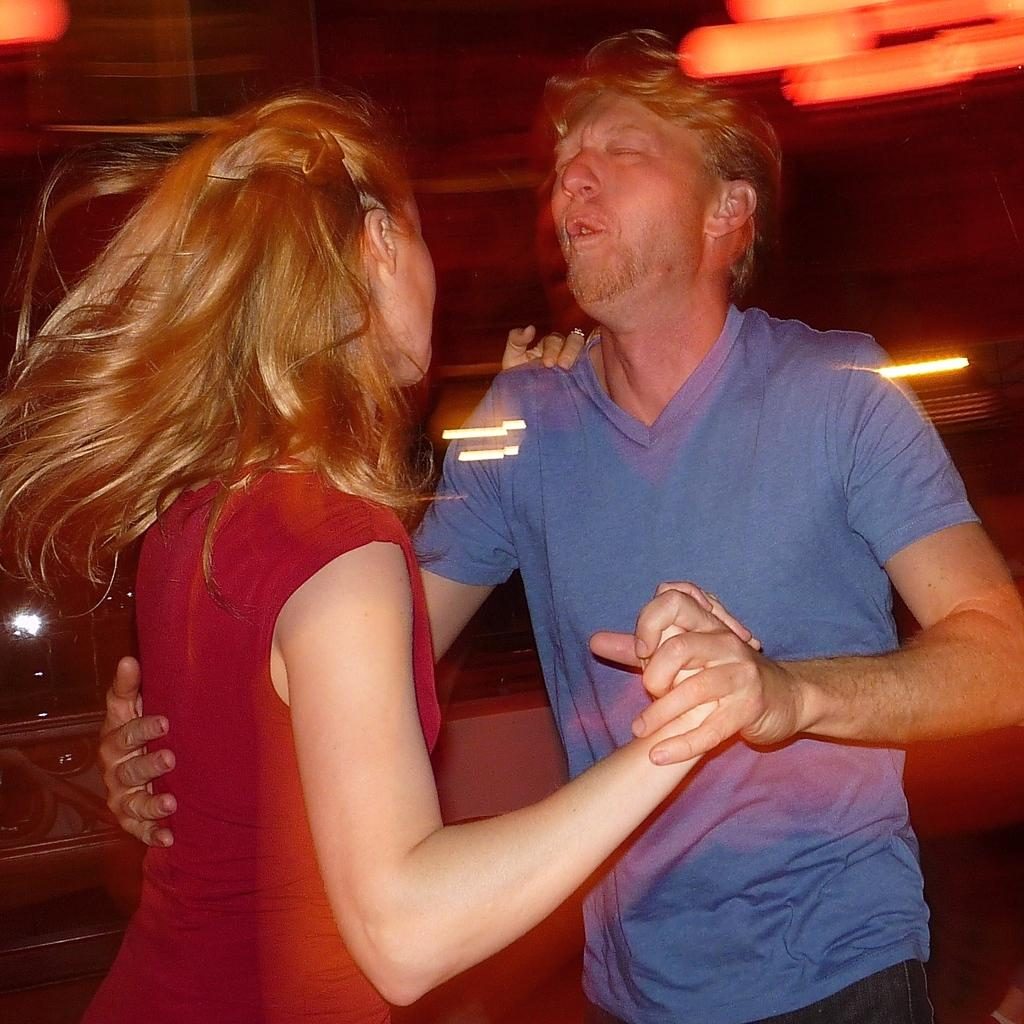What is the main subject of the image? There is a person in the image. What is the person wearing? The person is wearing a blue shirt. Who is the person interacting with in the image? The person is holding a woman's hand. What is the woman wearing? The woman is wearing a red dress. What activity are the person and the woman engaged in? Both the person and the woman are dancing. What can be seen at the top of the image? There are lights visible at the top of the image. What type of cherries can be seen in the person's drink in the image? There is no drink or cherries present in the image; the person is holding a woman's hand while dancing. Can you tell me the credit score of the person in the image? There is no information about the person's credit score in the image. 